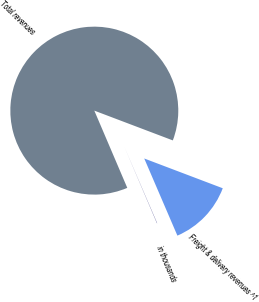Convert chart to OTSL. <chart><loc_0><loc_0><loc_500><loc_500><pie_chart><fcel>in thousands<fcel>Total revenues<fcel>Freight & delivery revenues ^1<nl><fcel>0.04%<fcel>87.19%<fcel>12.77%<nl></chart> 